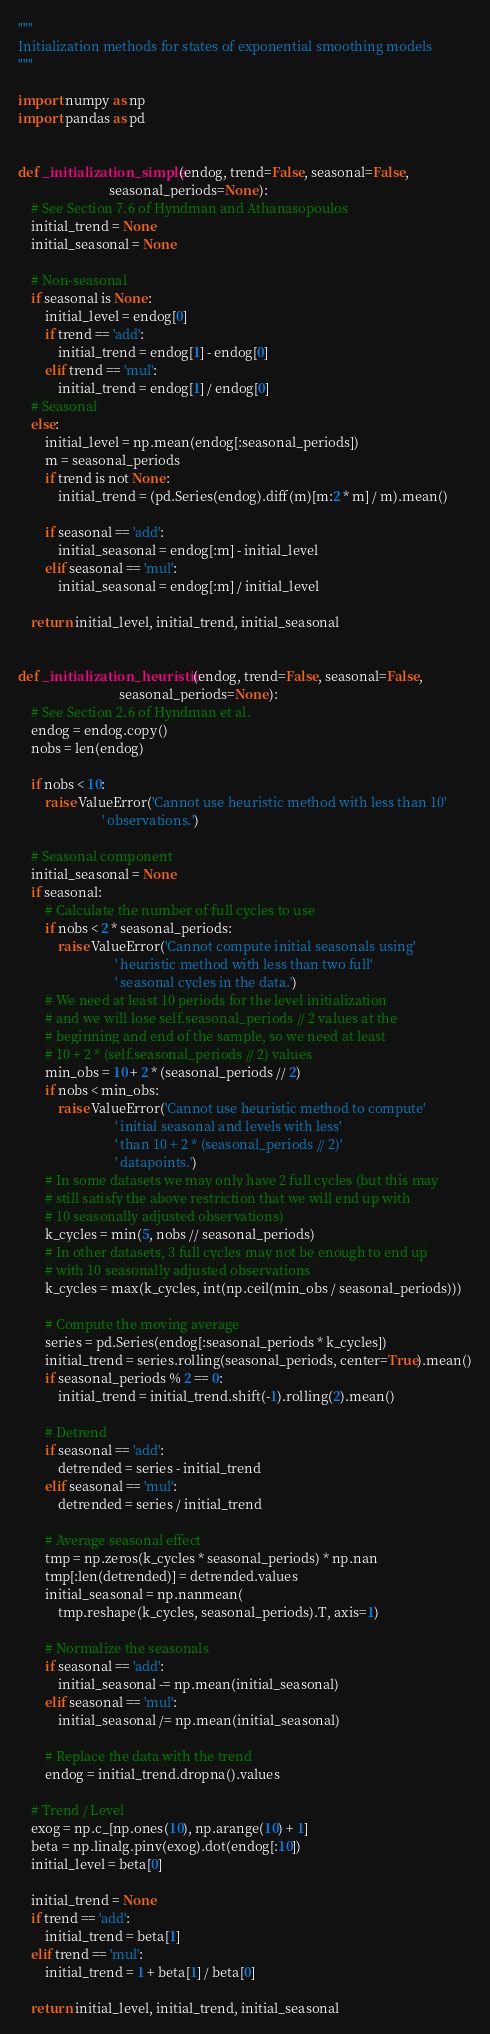<code> <loc_0><loc_0><loc_500><loc_500><_Python_>"""
Initialization methods for states of exponential smoothing models
"""

import numpy as np
import pandas as pd


def _initialization_simple(endog, trend=False, seasonal=False,
                           seasonal_periods=None):
    # See Section 7.6 of Hyndman and Athanasopoulos
    initial_trend = None
    initial_seasonal = None

    # Non-seasonal
    if seasonal is None:
        initial_level = endog[0]
        if trend == 'add':
            initial_trend = endog[1] - endog[0]
        elif trend == 'mul':
            initial_trend = endog[1] / endog[0]
    # Seasonal
    else:
        initial_level = np.mean(endog[:seasonal_periods])
        m = seasonal_periods
        if trend is not None:
            initial_trend = (pd.Series(endog).diff(m)[m:2 * m] / m).mean()

        if seasonal == 'add':
            initial_seasonal = endog[:m] - initial_level
        elif seasonal == 'mul':
            initial_seasonal = endog[:m] / initial_level

    return initial_level, initial_trend, initial_seasonal


def _initialization_heuristic(endog, trend=False, seasonal=False,
                              seasonal_periods=None):
    # See Section 2.6 of Hyndman et al.
    endog = endog.copy()
    nobs = len(endog)

    if nobs < 10:
        raise ValueError('Cannot use heuristic method with less than 10'
                         ' observations.')

    # Seasonal component
    initial_seasonal = None
    if seasonal:
        # Calculate the number of full cycles to use
        if nobs < 2 * seasonal_periods:
            raise ValueError('Cannot compute initial seasonals using'
                             ' heuristic method with less than two full'
                             ' seasonal cycles in the data.')
        # We need at least 10 periods for the level initialization
        # and we will lose self.seasonal_periods // 2 values at the
        # beginning and end of the sample, so we need at least
        # 10 + 2 * (self.seasonal_periods // 2) values
        min_obs = 10 + 2 * (seasonal_periods // 2)
        if nobs < min_obs:
            raise ValueError('Cannot use heuristic method to compute'
                             ' initial seasonal and levels with less'
                             ' than 10 + 2 * (seasonal_periods // 2)'
                             ' datapoints.')
        # In some datasets we may only have 2 full cycles (but this may
        # still satisfy the above restriction that we will end up with
        # 10 seasonally adjusted observations)
        k_cycles = min(5, nobs // seasonal_periods)
        # In other datasets, 3 full cycles may not be enough to end up
        # with 10 seasonally adjusted observations
        k_cycles = max(k_cycles, int(np.ceil(min_obs / seasonal_periods)))

        # Compute the moving average
        series = pd.Series(endog[:seasonal_periods * k_cycles])
        initial_trend = series.rolling(seasonal_periods, center=True).mean()
        if seasonal_periods % 2 == 0:
            initial_trend = initial_trend.shift(-1).rolling(2).mean()

        # Detrend
        if seasonal == 'add':
            detrended = series - initial_trend
        elif seasonal == 'mul':
            detrended = series / initial_trend

        # Average seasonal effect
        tmp = np.zeros(k_cycles * seasonal_periods) * np.nan
        tmp[:len(detrended)] = detrended.values
        initial_seasonal = np.nanmean(
            tmp.reshape(k_cycles, seasonal_periods).T, axis=1)

        # Normalize the seasonals
        if seasonal == 'add':
            initial_seasonal -= np.mean(initial_seasonal)
        elif seasonal == 'mul':
            initial_seasonal /= np.mean(initial_seasonal)

        # Replace the data with the trend
        endog = initial_trend.dropna().values

    # Trend / Level
    exog = np.c_[np.ones(10), np.arange(10) + 1]
    beta = np.linalg.pinv(exog).dot(endog[:10])
    initial_level = beta[0]

    initial_trend = None
    if trend == 'add':
        initial_trend = beta[1]
    elif trend == 'mul':
        initial_trend = 1 + beta[1] / beta[0]

    return initial_level, initial_trend, initial_seasonal
</code> 